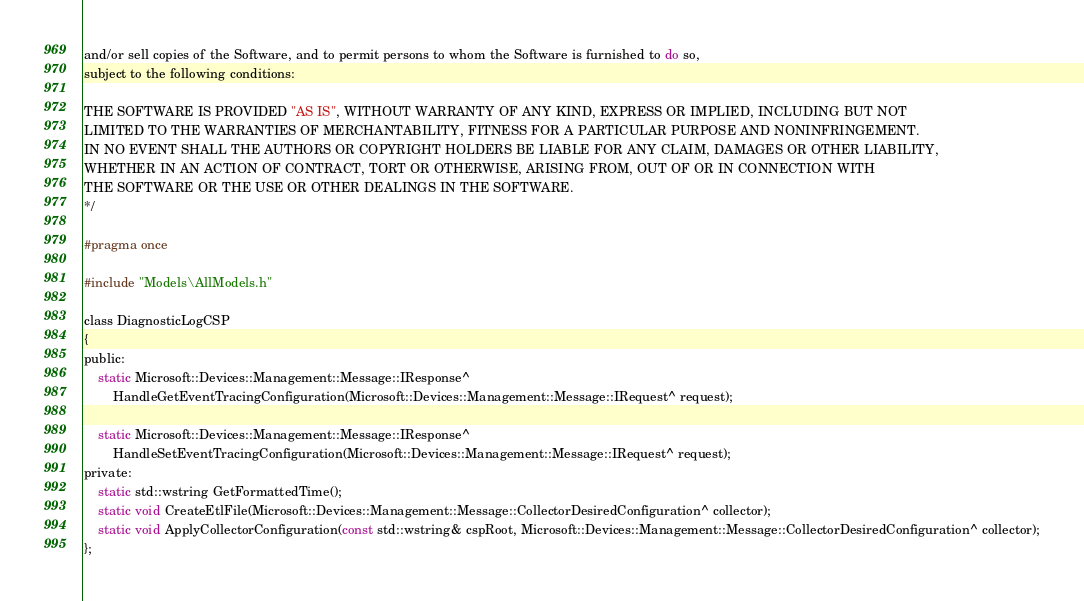<code> <loc_0><loc_0><loc_500><loc_500><_C_>and/or sell copies of the Software, and to permit persons to whom the Software is furnished to do so,
subject to the following conditions:

THE SOFTWARE IS PROVIDED "AS IS", WITHOUT WARRANTY OF ANY KIND, EXPRESS OR IMPLIED, INCLUDING BUT NOT
LIMITED TO THE WARRANTIES OF MERCHANTABILITY, FITNESS FOR A PARTICULAR PURPOSE AND NONINFRINGEMENT.
IN NO EVENT SHALL THE AUTHORS OR COPYRIGHT HOLDERS BE LIABLE FOR ANY CLAIM, DAMAGES OR OTHER LIABILITY,
WHETHER IN AN ACTION OF CONTRACT, TORT OR OTHERWISE, ARISING FROM, OUT OF OR IN CONNECTION WITH
THE SOFTWARE OR THE USE OR OTHER DEALINGS IN THE SOFTWARE.
*/

#pragma once

#include "Models\AllModels.h"

class DiagnosticLogCSP
{
public:
    static Microsoft::Devices::Management::Message::IResponse^ 
        HandleGetEventTracingConfiguration(Microsoft::Devices::Management::Message::IRequest^ request);

    static Microsoft::Devices::Management::Message::IResponse^
        HandleSetEventTracingConfiguration(Microsoft::Devices::Management::Message::IRequest^ request);
private:
    static std::wstring GetFormattedTime();
    static void CreateEtlFile(Microsoft::Devices::Management::Message::CollectorDesiredConfiguration^ collector);
    static void ApplyCollectorConfiguration(const std::wstring& cspRoot, Microsoft::Devices::Management::Message::CollectorDesiredConfiguration^ collector);
};</code> 